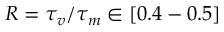Convert formula to latex. <formula><loc_0><loc_0><loc_500><loc_500>R = \tau _ { v } / \tau _ { m } \in [ 0 . 4 - 0 . 5 ]</formula> 